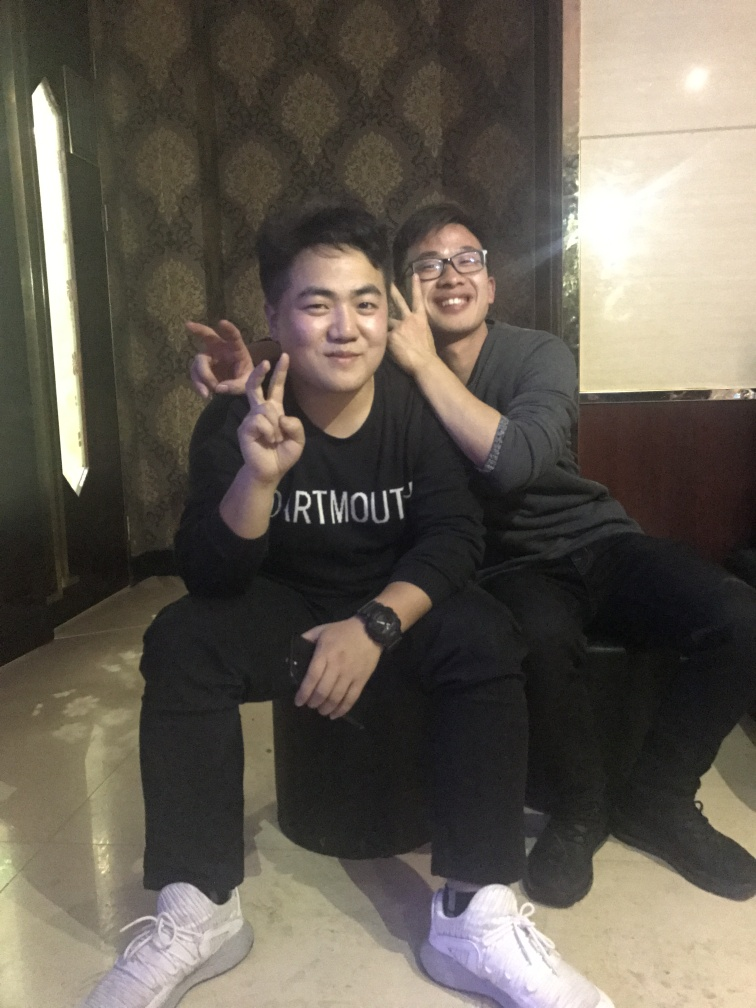What can you infer about the relationship between the two people in this image? Based on their proximity and physical interaction, with one person's hand on the other's face, it suggests a familiarity and comfort with each other that often indicates a close friendship or a strong bond. Their expressions and gestures imply they share a good rapport. 